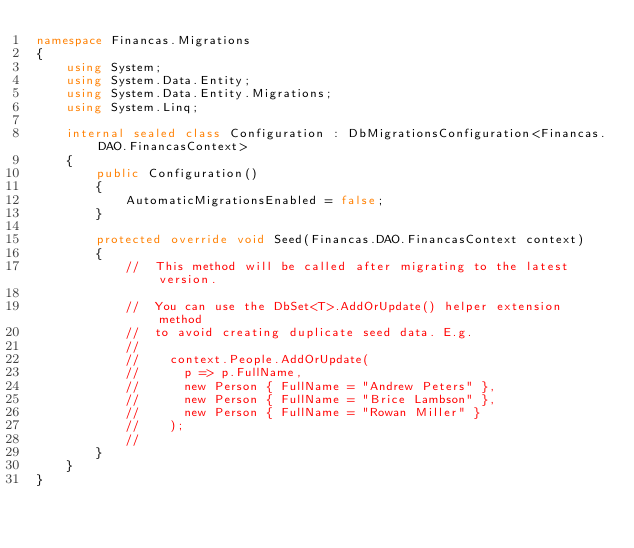<code> <loc_0><loc_0><loc_500><loc_500><_C#_>namespace Financas.Migrations
{
    using System;
    using System.Data.Entity;
    using System.Data.Entity.Migrations;
    using System.Linq;

    internal sealed class Configuration : DbMigrationsConfiguration<Financas.DAO.FinancasContext>
    {
        public Configuration()
        {
            AutomaticMigrationsEnabled = false;
        }

        protected override void Seed(Financas.DAO.FinancasContext context)
        {
            //  This method will be called after migrating to the latest version.

            //  You can use the DbSet<T>.AddOrUpdate() helper extension method 
            //  to avoid creating duplicate seed data. E.g.
            //
            //    context.People.AddOrUpdate(
            //      p => p.FullName,
            //      new Person { FullName = "Andrew Peters" },
            //      new Person { FullName = "Brice Lambson" },
            //      new Person { FullName = "Rowan Miller" }
            //    );
            //
        }
    }
}
</code> 